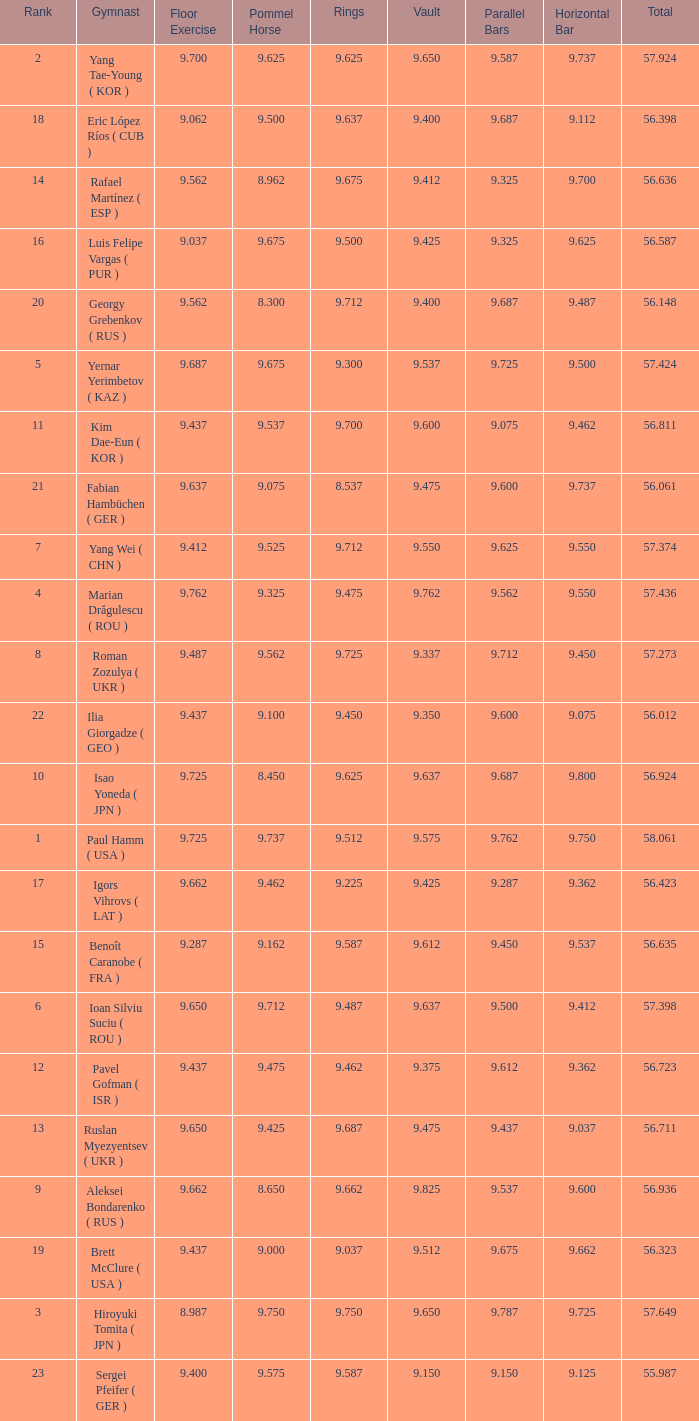What is the vault score for the total of 56.635? 9.612. 